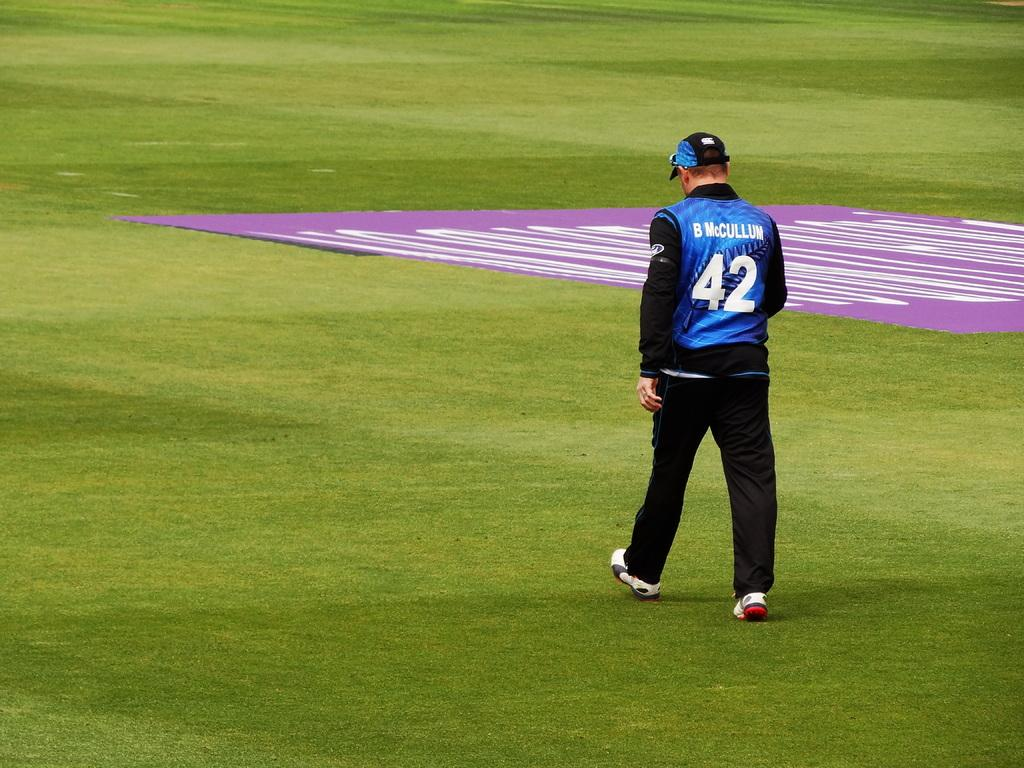<image>
Summarize the visual content of the image. A man wearing B McCullum's jersey is walking on the field. 